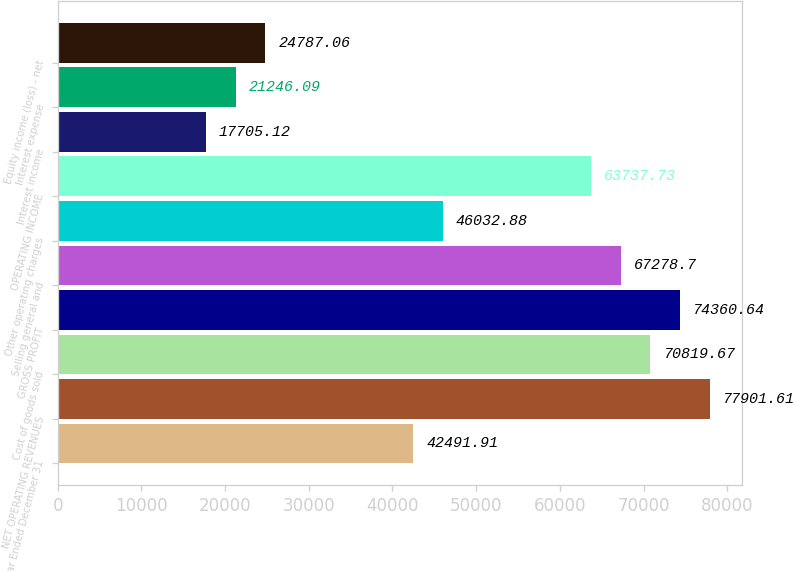Convert chart to OTSL. <chart><loc_0><loc_0><loc_500><loc_500><bar_chart><fcel>Year Ended December 31<fcel>NET OPERATING REVENUES<fcel>Cost of goods sold<fcel>GROSS PROFIT<fcel>Selling general and<fcel>Other operating charges<fcel>OPERATING INCOME<fcel>Interest income<fcel>Interest expense<fcel>Equity income (loss) - net<nl><fcel>42491.9<fcel>77901.6<fcel>70819.7<fcel>74360.6<fcel>67278.7<fcel>46032.9<fcel>63737.7<fcel>17705.1<fcel>21246.1<fcel>24787.1<nl></chart> 